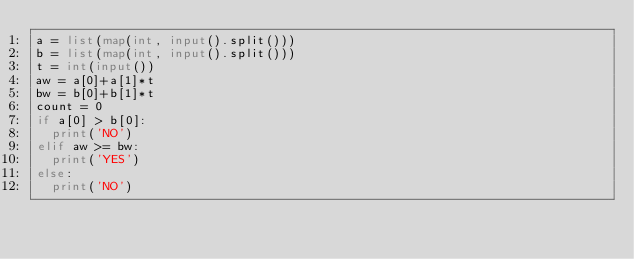Convert code to text. <code><loc_0><loc_0><loc_500><loc_500><_Python_>a = list(map(int, input().split()))
b = list(map(int, input().split()))
t = int(input())
aw = a[0]+a[1]*t
bw = b[0]+b[1]*t
count = 0
if a[0] > b[0]:
  print('NO')
elif aw >= bw:
  print('YES')
else:
  print('NO')</code> 